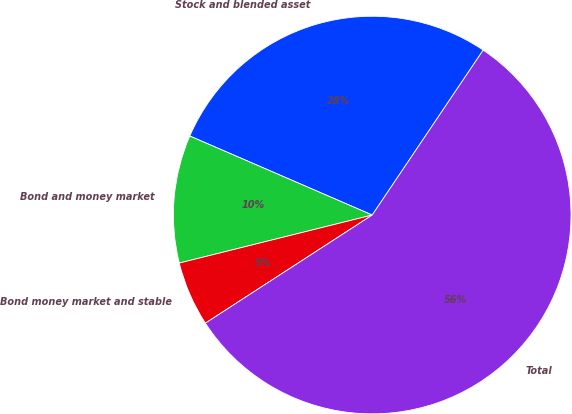Convert chart. <chart><loc_0><loc_0><loc_500><loc_500><pie_chart><fcel>Stock and blended asset<fcel>Bond and money market<fcel>Bond money market and stable<fcel>Total<nl><fcel>27.92%<fcel>10.39%<fcel>5.27%<fcel>56.42%<nl></chart> 